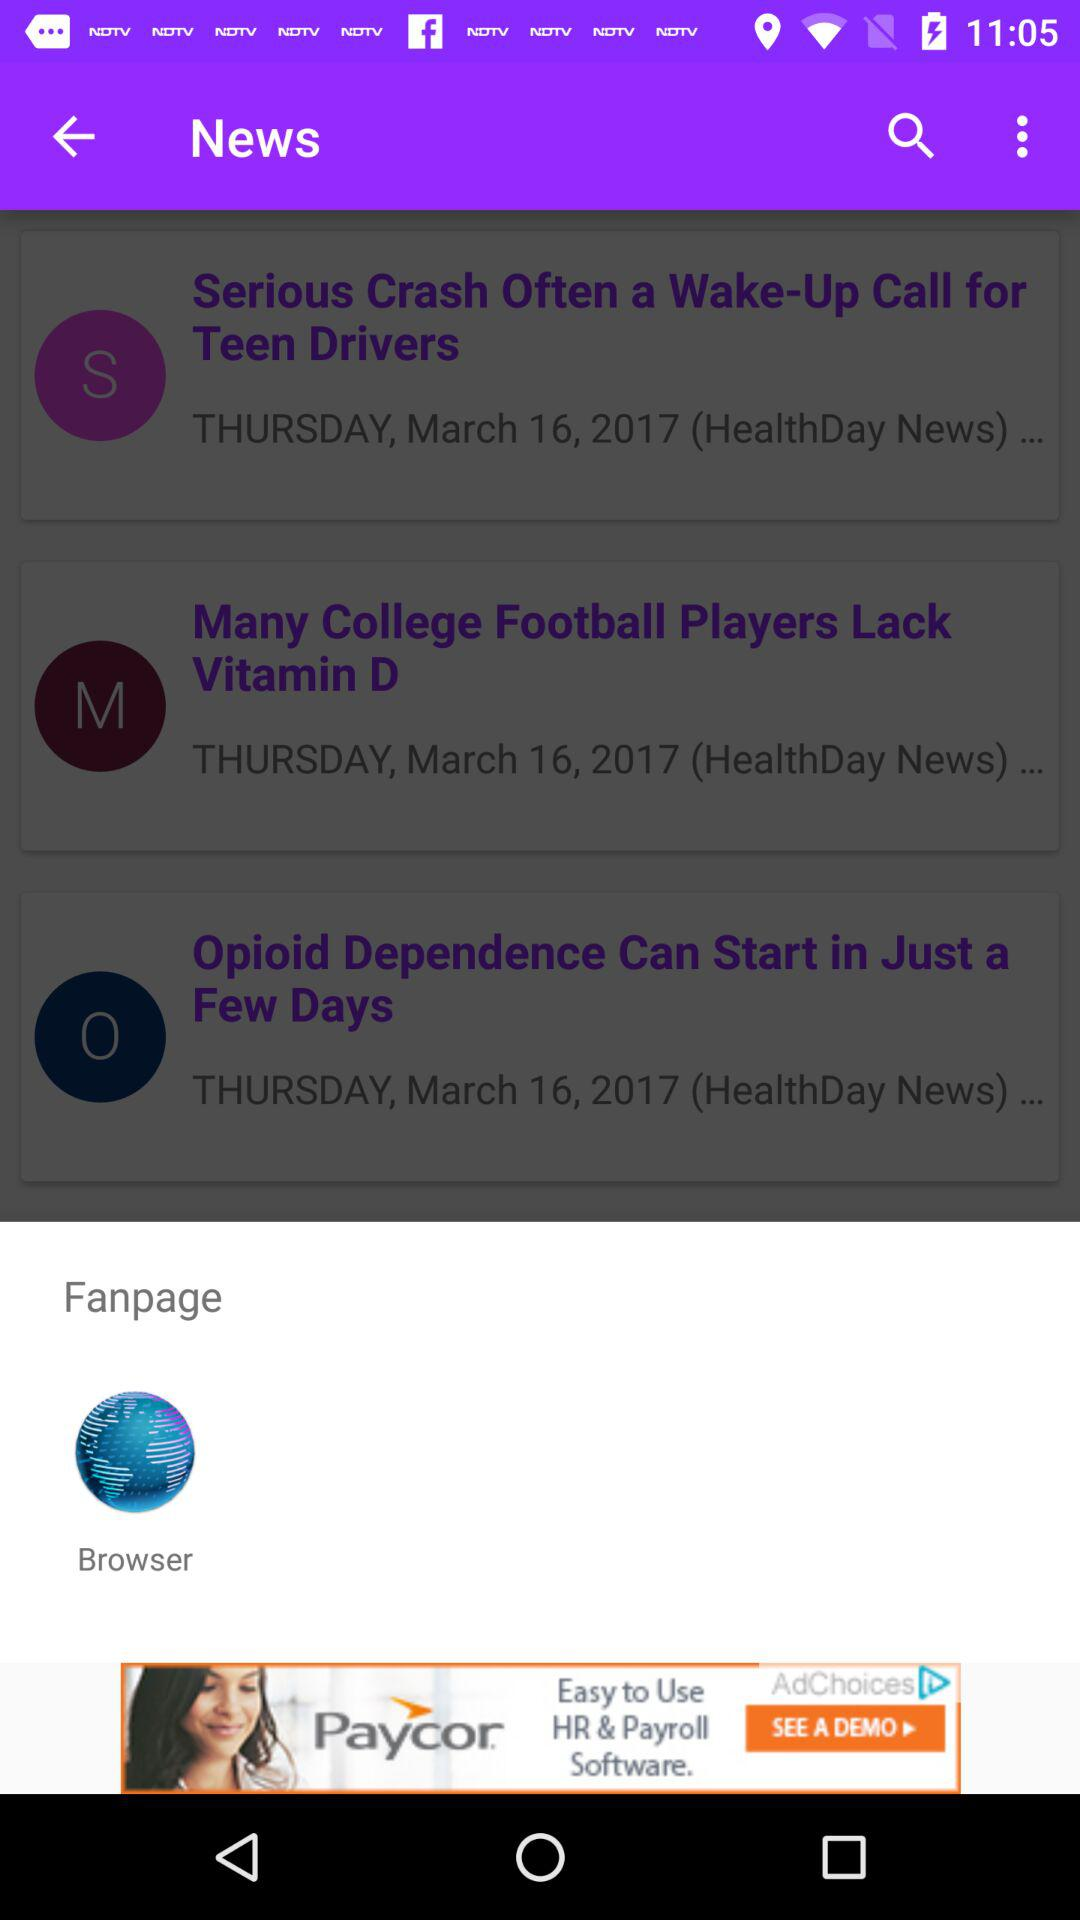Which fanpage has given?
When the provided information is insufficient, respond with <no answer>. <no answer> 